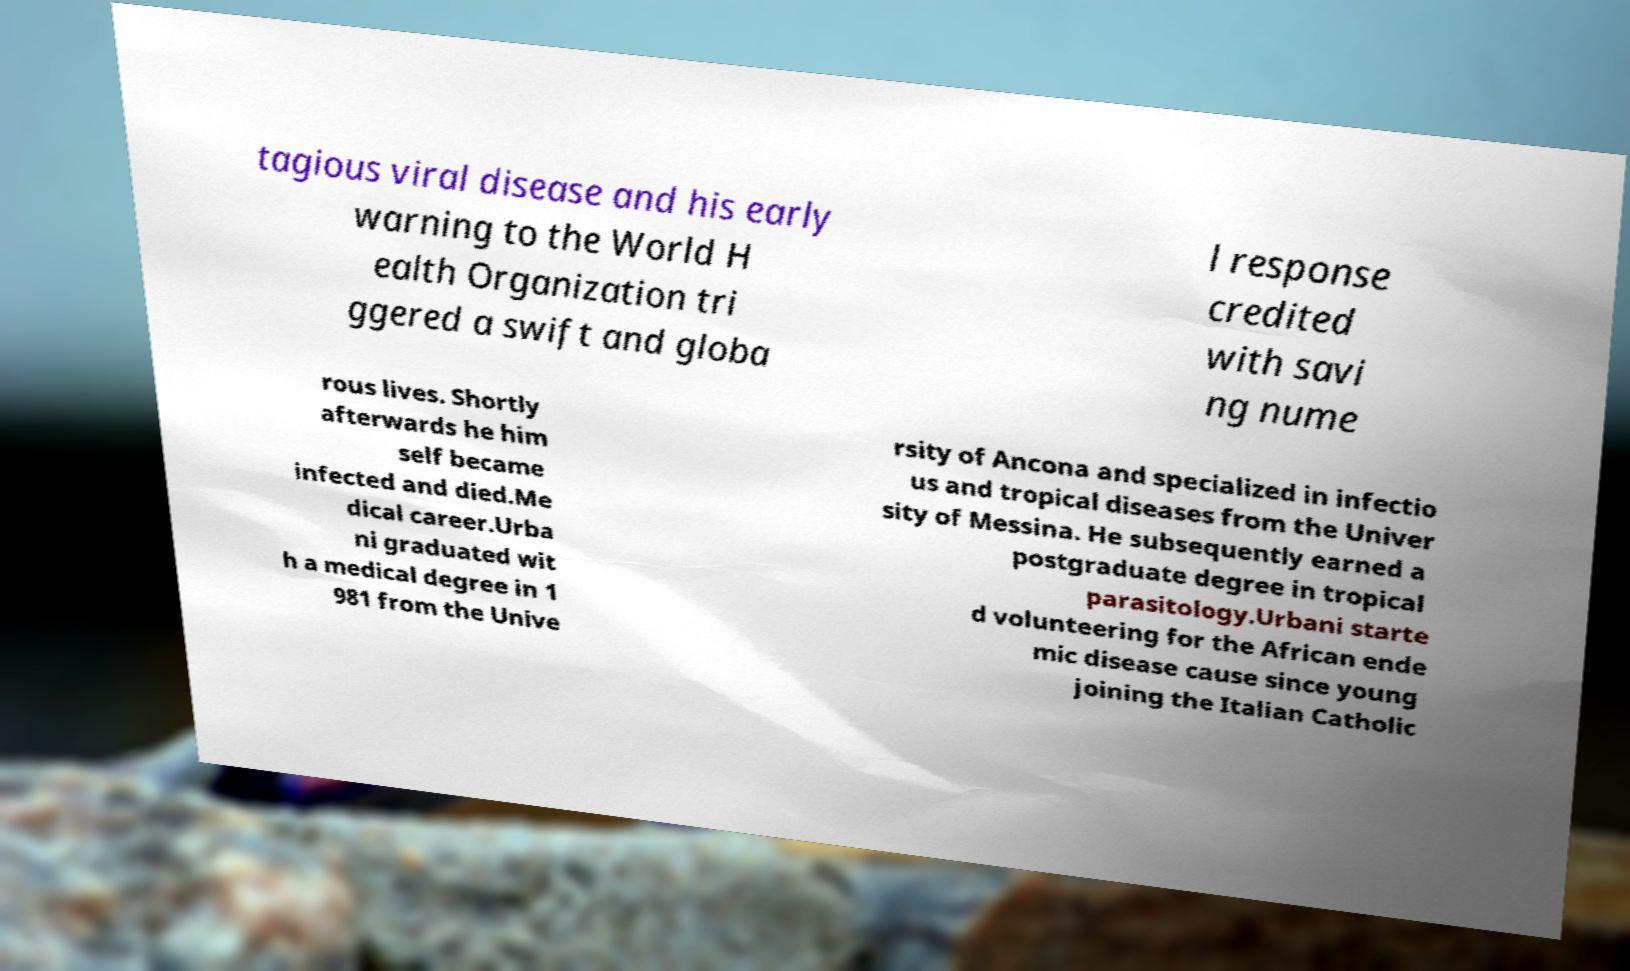Could you assist in decoding the text presented in this image and type it out clearly? tagious viral disease and his early warning to the World H ealth Organization tri ggered a swift and globa l response credited with savi ng nume rous lives. Shortly afterwards he him self became infected and died.Me dical career.Urba ni graduated wit h a medical degree in 1 981 from the Unive rsity of Ancona and specialized in infectio us and tropical diseases from the Univer sity of Messina. He subsequently earned a postgraduate degree in tropical parasitology.Urbani starte d volunteering for the African ende mic disease cause since young joining the Italian Catholic 